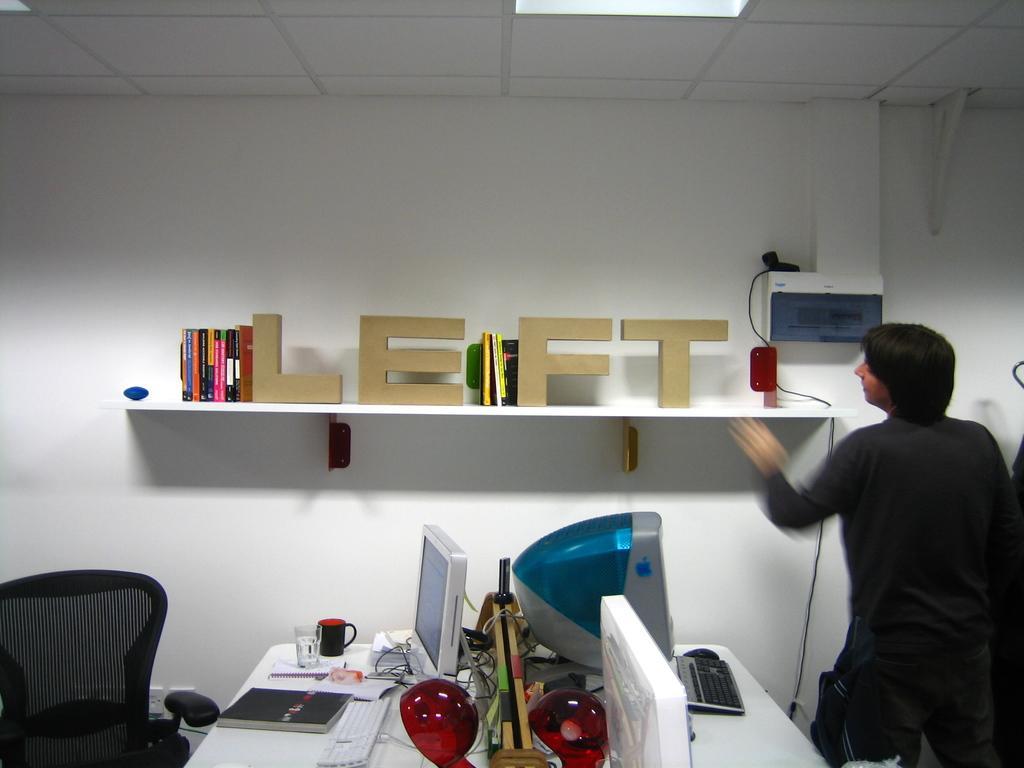Can you describe this image briefly? In the center of the image there is a table and on top of the table there are monitors, keyboards, books, cup, glass and a few other objects. At the right side of the image there is a chair. On the right side of the image there is a person. On the backside there is a shelf and on top of it there are books and we can see a wooden letters. Behind the shelf there's a wall. On top the image there is a ceiling. 